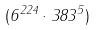Convert formula to latex. <formula><loc_0><loc_0><loc_500><loc_500>( 6 ^ { 2 2 4 } \cdot 3 8 3 ^ { 5 } )</formula> 